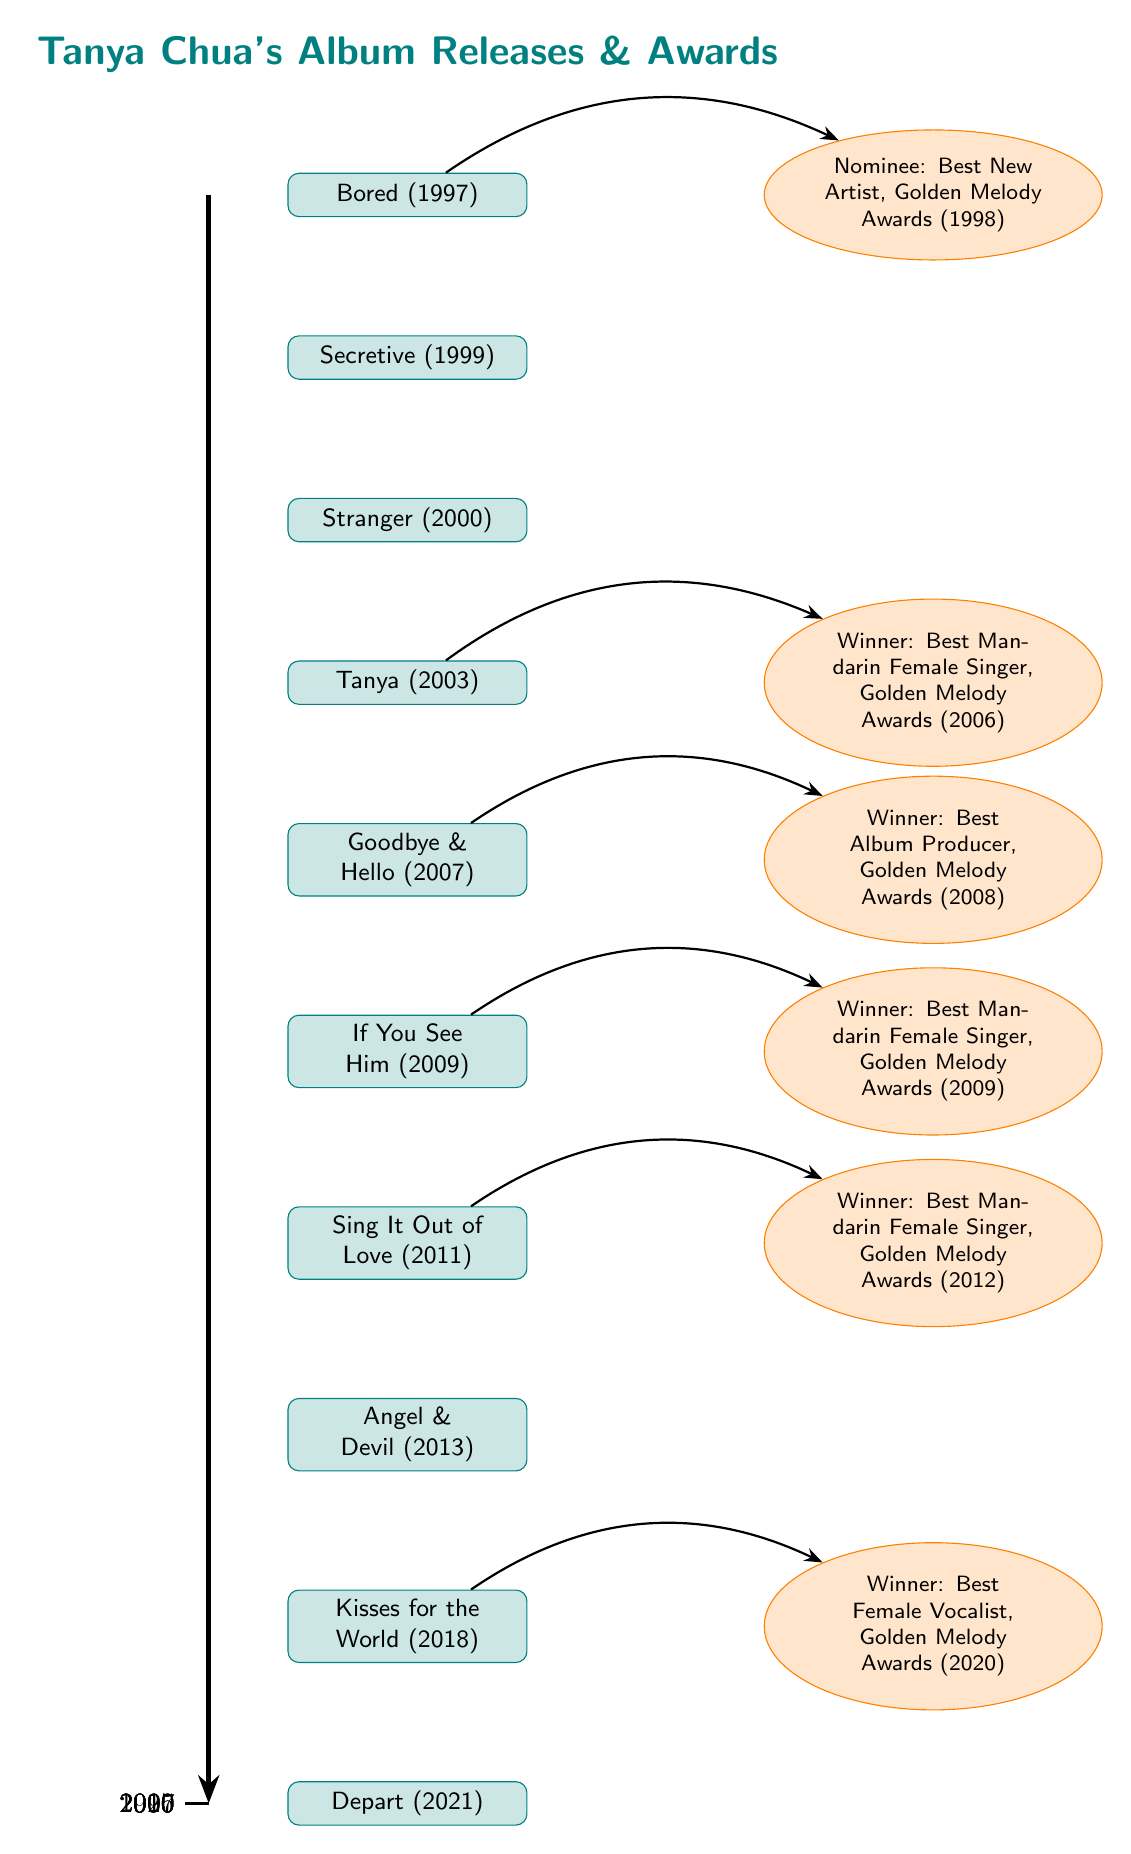What is the title of Tanya Chua's first album? The diagram indicates that her first album, shown at the top, is "Bored."
Answer: Bored How many albums did Tanya Chua release by 2021? Counting all the albums listed in the diagram, from "Bored" to "Depart," we find a total of ten albums.
Answer: 10 Which album won the Best Mandarin Female Singer award in 2006? Referring to the awards section, we see that the award linked to "Tanya" (2003) indicates it as the winner for Best Mandarin Female Singer in 2006.
Answer: Tanya How many awards does Tanya Chua have listed in the diagram? Looking at the awards nodes present in the diagram, there are six distinct awards listed beside the relevant albums.
Answer: 6 What year was the album "Angel & Devil" released? The diagram shows that "Angel & Devil" is positioned vertically below "Sing It Out of Love" (2011) and above "Kisses for the World" (2018), indicating it was released in 2013.
Answer: 2013 Which album is linked to the award for Best Female Vocalist in 2020? The diagram shows that the award node for Best Female Vocalist in 2020 is connected to the album "Kisses for the World" (2018).
Answer: Kisses for the World Which album marked Tanya Chua's return with the title "Depart"? The last album in the sequence is "Depart," so it directly marks her recent release listed in the diagram.
Answer: Depart In what year did Tanya Chua receive the award for Best Album Producer? The diagram denotes that the award for Best Album Producer correlates with the album "Goodbye & Hello" released in 2007, which won the award in 2008.
Answer: 2008 